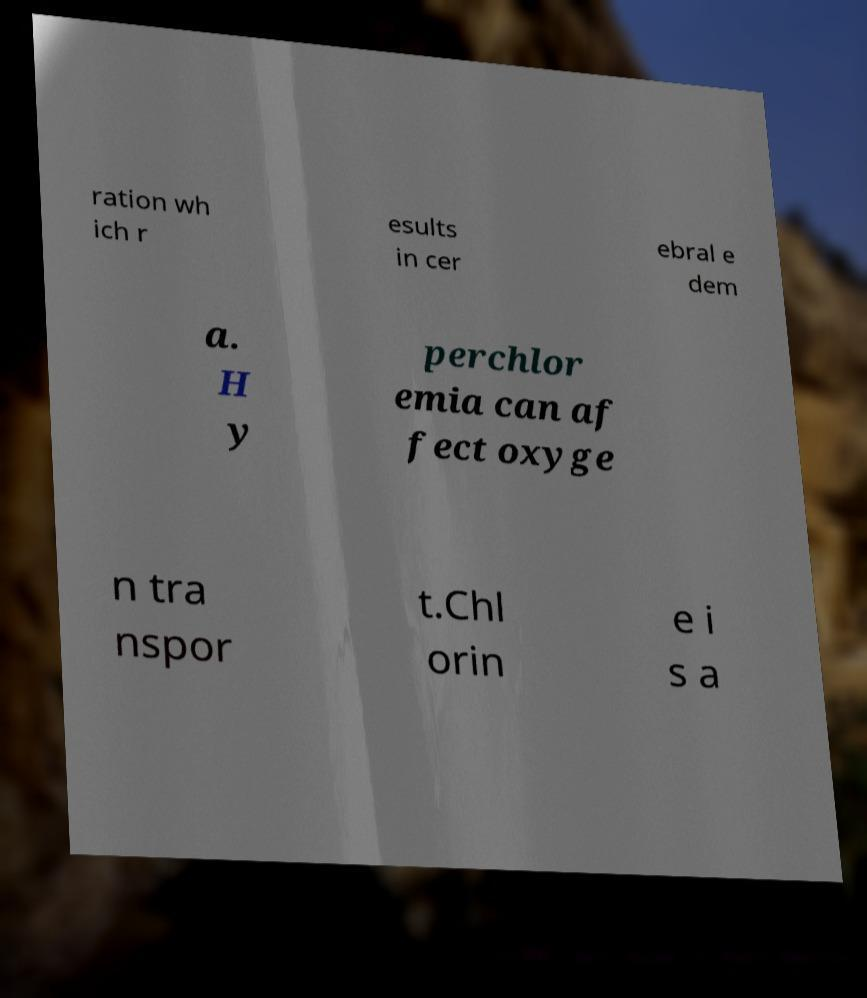What messages or text are displayed in this image? I need them in a readable, typed format. ration wh ich r esults in cer ebral e dem a. H y perchlor emia can af fect oxyge n tra nspor t.Chl orin e i s a 